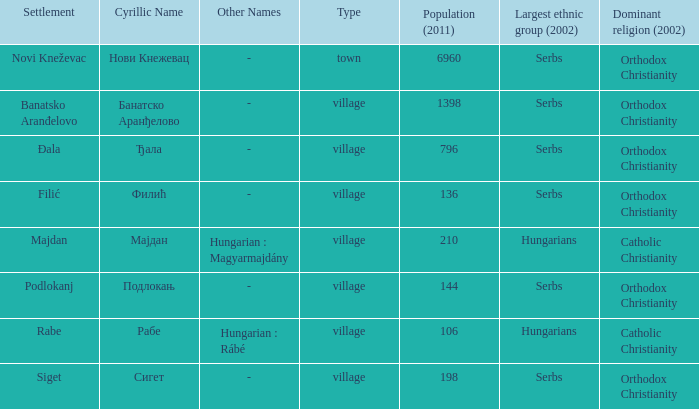In the settlement with the cyrillic designation банатско аранђелово, which ethnic group is the most populous? Serbs. 